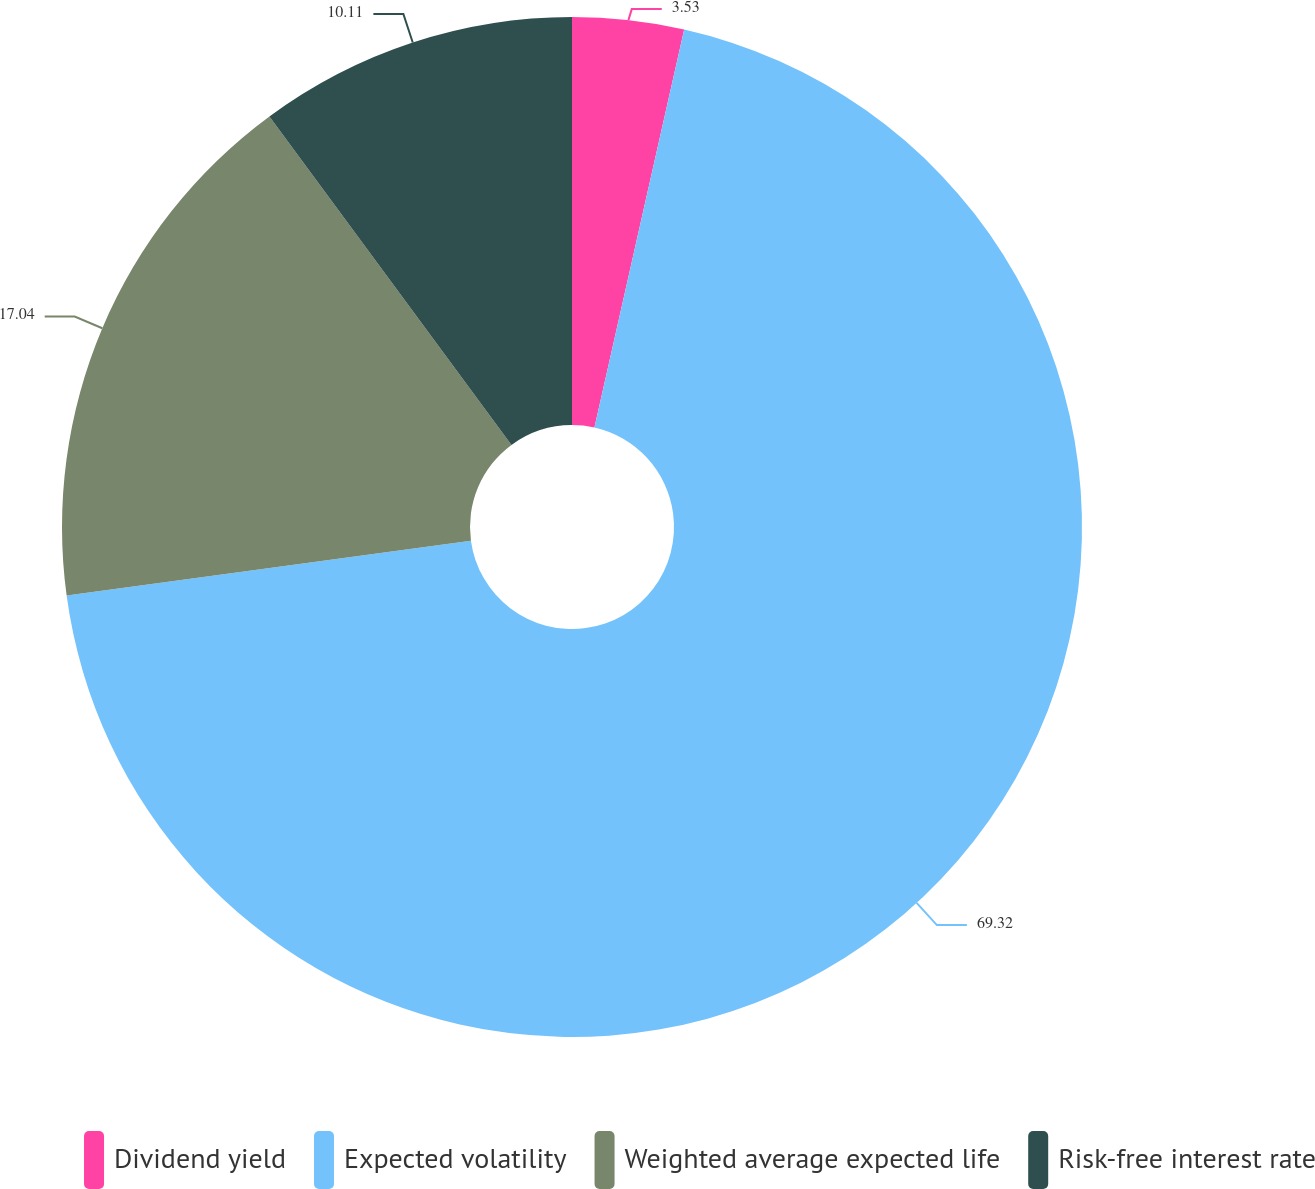Convert chart. <chart><loc_0><loc_0><loc_500><loc_500><pie_chart><fcel>Dividend yield<fcel>Expected volatility<fcel>Weighted average expected life<fcel>Risk-free interest rate<nl><fcel>3.53%<fcel>69.33%<fcel>17.04%<fcel>10.11%<nl></chart> 